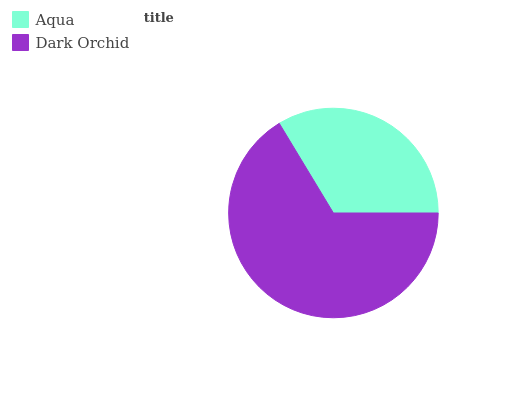Is Aqua the minimum?
Answer yes or no. Yes. Is Dark Orchid the maximum?
Answer yes or no. Yes. Is Dark Orchid the minimum?
Answer yes or no. No. Is Dark Orchid greater than Aqua?
Answer yes or no. Yes. Is Aqua less than Dark Orchid?
Answer yes or no. Yes. Is Aqua greater than Dark Orchid?
Answer yes or no. No. Is Dark Orchid less than Aqua?
Answer yes or no. No. Is Dark Orchid the high median?
Answer yes or no. Yes. Is Aqua the low median?
Answer yes or no. Yes. Is Aqua the high median?
Answer yes or no. No. Is Dark Orchid the low median?
Answer yes or no. No. 